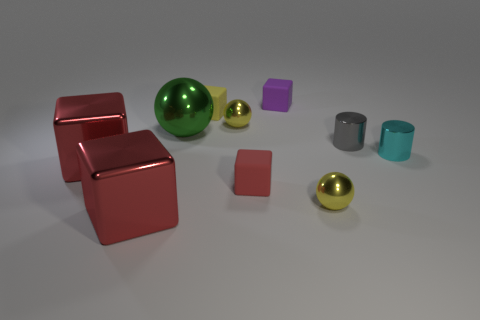Subtract all balls. How many objects are left? 7 Subtract all yellow cubes. How many cubes are left? 4 Subtract all metallic blocks. How many blocks are left? 3 Subtract 2 balls. How many balls are left? 1 Subtract all cyan spheres. How many brown blocks are left? 0 Subtract all small purple objects. Subtract all cyan metallic things. How many objects are left? 8 Add 5 large metal cubes. How many large metal cubes are left? 7 Add 7 big blue metal objects. How many big blue metal objects exist? 7 Subtract 1 gray cylinders. How many objects are left? 9 Subtract all red blocks. Subtract all green cylinders. How many blocks are left? 2 